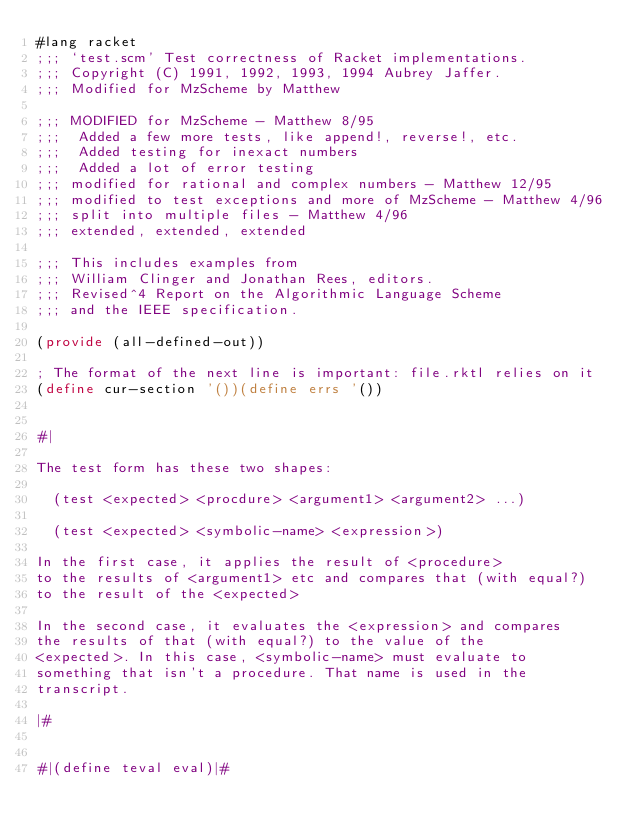Convert code to text. <code><loc_0><loc_0><loc_500><loc_500><_Racket_>#lang racket
;;; `test.scm' Test correctness of Racket implementations.
;;; Copyright (C) 1991, 1992, 1993, 1994 Aubrey Jaffer.
;;; Modified for MzScheme by Matthew

;;; MODIFIED for MzScheme - Matthew 8/95
;;;  Added a few more tests, like append!, reverse!, etc.
;;;  Added testing for inexact numbers
;;;  Added a lot of error testing
;;; modified for rational and complex numbers - Matthew 12/95
;;; modified to test exceptions and more of MzScheme - Matthew 4/96
;;; split into multiple files - Matthew 4/96
;;; extended, extended, extended

;;; This includes examples from
;;; William Clinger and Jonathan Rees, editors.
;;; Revised^4 Report on the Algorithmic Language Scheme
;;; and the IEEE specification.

(provide (all-defined-out))

; The format of the next line is important: file.rktl relies on it
(define cur-section '())(define errs '())


#|

The test form has these two shapes:

  (test <expected> <procdure> <argument1> <argument2> ...)

  (test <expected> <symbolic-name> <expression>)

In the first case, it applies the result of <procedure>
to the results of <argument1> etc and compares that (with equal?)
to the result of the <expected>

In the second case, it evaluates the <expression> and compares
the results of that (with equal?) to the value of the
<expected>. In this case, <symbolic-name> must evaluate to
something that isn't a procedure. That name is used in the
transcript.

|#


#|(define teval eval)|#
</code> 